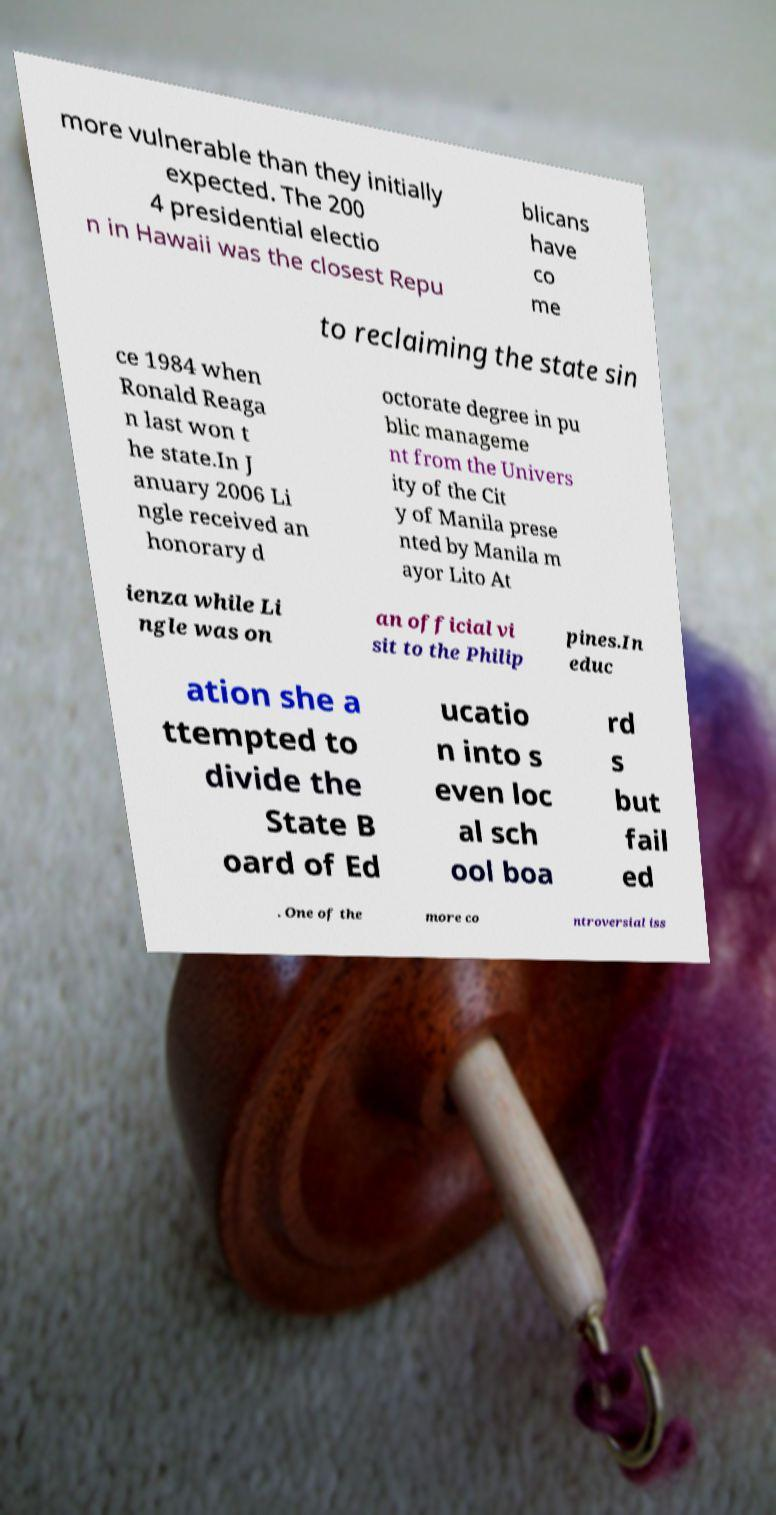There's text embedded in this image that I need extracted. Can you transcribe it verbatim? more vulnerable than they initially expected. The 200 4 presidential electio n in Hawaii was the closest Repu blicans have co me to reclaiming the state sin ce 1984 when Ronald Reaga n last won t he state.In J anuary 2006 Li ngle received an honorary d octorate degree in pu blic manageme nt from the Univers ity of the Cit y of Manila prese nted by Manila m ayor Lito At ienza while Li ngle was on an official vi sit to the Philip pines.In educ ation she a ttempted to divide the State B oard of Ed ucatio n into s even loc al sch ool boa rd s but fail ed . One of the more co ntroversial iss 